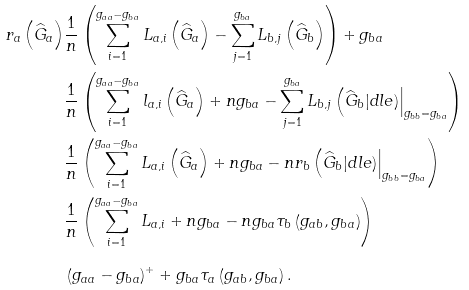<formula> <loc_0><loc_0><loc_500><loc_500>r _ { a } \left ( \widehat { G } _ { a } \right ) & \frac { 1 } { n } \left ( \sum _ { i = 1 } ^ { g _ { a a } - g _ { b a } } L _ { a , i } \left ( \widehat { G } _ { a } \right ) - \sum _ { j = 1 } ^ { g _ { b a } } L _ { b , j } \left ( \widehat { G } _ { b } \right ) \right ) + g _ { b a } \\ & \frac { 1 } { n } \left ( \sum _ { i = 1 } ^ { g _ { a a } - g _ { b a } } l _ { a , i } \left ( \widehat { G } _ { a } \right ) + n g _ { b a } - \sum _ { j = 1 } ^ { g _ { b a } } L _ { b , j } \left ( \widehat { G } _ { b } | d l e ) \right | _ { g _ { b b } = g _ { b a } } \right ) \\ & \frac { 1 } { n } \left ( \sum _ { i = 1 } ^ { g _ { a a } - g _ { b a } } L _ { a , i } \left ( \widehat { G } _ { a } \right ) + n g _ { b a } - n r _ { b } \left ( \widehat { G } _ { b } | d l e ) \right | _ { g _ { b b } = g _ { b a } } \right ) \\ & \frac { 1 } { n } \left ( \sum _ { i = 1 } ^ { g _ { a a } - g _ { b a } } L _ { a , i } + n g _ { b a } - n g _ { b a } \tau _ { b } \left ( g _ { a b } , g _ { b a } \right ) \right ) \\ & \left ( g _ { a a } - g _ { b a } \right ) ^ { + } + g _ { b a } \tau _ { a } \left ( g _ { a b } , g _ { b a } \right ) .</formula> 